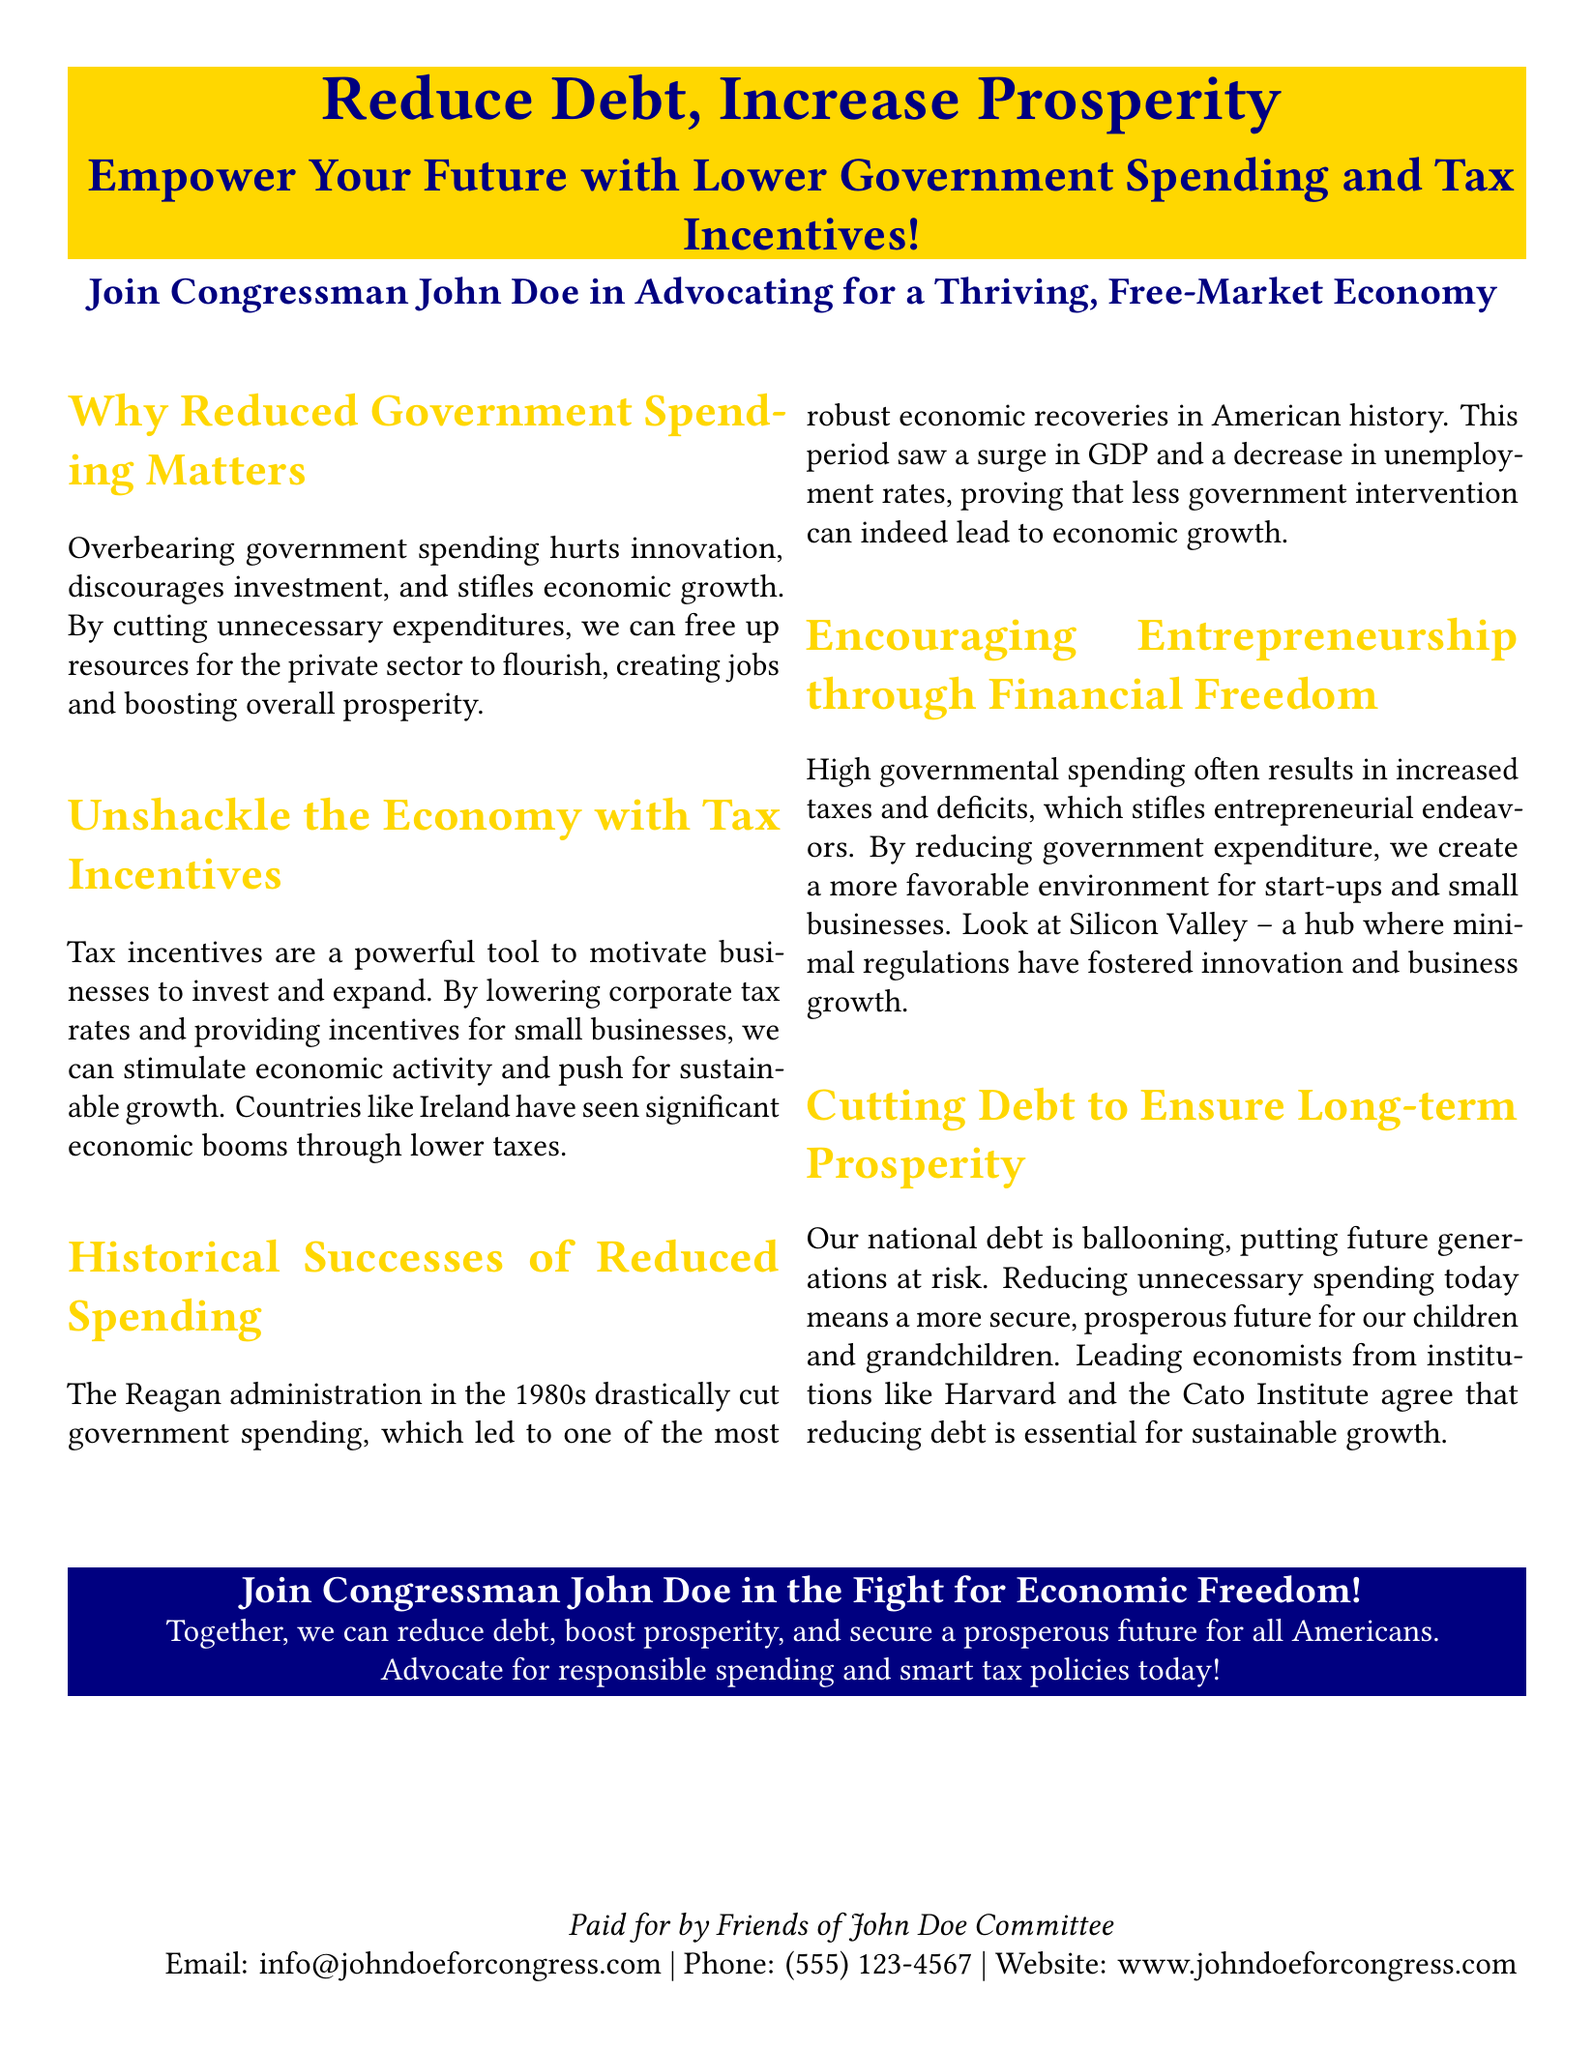What is the main theme of the advertisement? The advertisement primarily focuses on advocating for reduced government spending and tax incentives to encourage economic growth.
Answer: Reduce Debt, Increase Prosperity Who is the congressman mentioned in the advertisement? The advertisement highlights a specific congressman who is leading the advocacy for a free-market economy.
Answer: Congressman John Doe What historical example is provided as a success story of reduced spending? The advertisement cites a past administration that effectively reduced government spending and resulted in economic benefits.
Answer: The Reagan administration What color is used for the heading "Why Reduced Government Spending Matters"? The heading's color is consistent with the advertisement's theme and branding.
Answer: Libertygold Which economic theory is suggested as beneficial for small businesses? The advertisement mentions a specific concept that facilitates entrepreneurship by reducing financial constraints.
Answer: Tax incentives What is the contact email provided in the advertisement? The advertisement includes contact information for supporters who wish to connect with the campaign.
Answer: info@johndoeforcongress.com What does the advertisement suggest is at risk if national debt continues to grow? The document expresses concern about the consequences of increasing national debt on future generations.
Answer: Prosperity How does the advertisement claim lower corporate taxes affect the economy? The advertisement argues that a specific policy drives positive economic outcomes for businesses.
Answer: Stimulate economic activity 